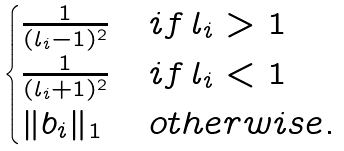Convert formula to latex. <formula><loc_0><loc_0><loc_500><loc_500>\begin{cases} \frac { 1 } { ( l _ { i } - 1 ) ^ { 2 } } & i f \, l _ { i } > 1 \\ \frac { 1 } { ( l _ { i } + 1 ) ^ { 2 } } & i f \, l _ { i } < 1 \\ \| b _ { i } \| _ { 1 } & { o t h e r w i s e . } \end{cases}</formula> 